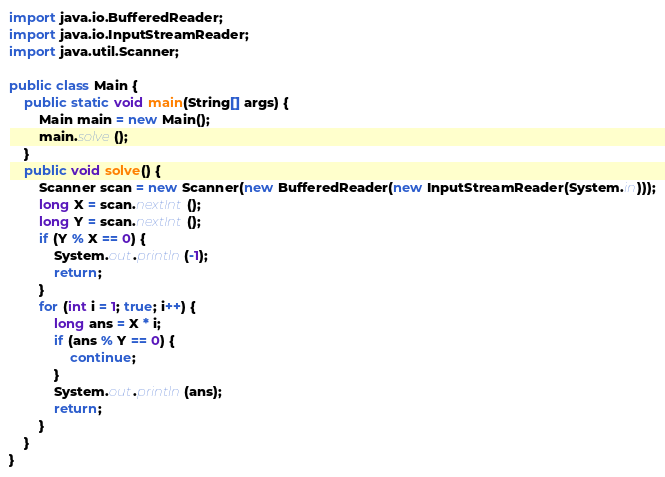Convert code to text. <code><loc_0><loc_0><loc_500><loc_500><_Java_>import java.io.BufferedReader;
import java.io.InputStreamReader;
import java.util.Scanner;

public class Main {
    public static void main(String[] args) {
        Main main = new Main();
        main.solve();
    }
    public void solve() {
        Scanner scan = new Scanner(new BufferedReader(new InputStreamReader(System.in)));
        long X = scan.nextInt();
        long Y = scan.nextInt();
        if (Y % X == 0) {
            System.out.println(-1);
            return;
        }
        for (int i = 1; true; i++) {
            long ans = X * i;
            if (ans % Y == 0) {
                continue;
            }
            System.out.println(ans);
            return;
        }
    }
}
</code> 